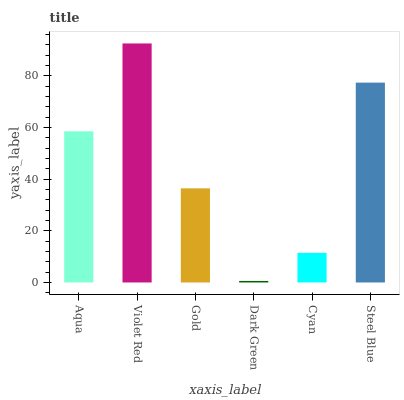Is Dark Green the minimum?
Answer yes or no. Yes. Is Violet Red the maximum?
Answer yes or no. Yes. Is Gold the minimum?
Answer yes or no. No. Is Gold the maximum?
Answer yes or no. No. Is Violet Red greater than Gold?
Answer yes or no. Yes. Is Gold less than Violet Red?
Answer yes or no. Yes. Is Gold greater than Violet Red?
Answer yes or no. No. Is Violet Red less than Gold?
Answer yes or no. No. Is Aqua the high median?
Answer yes or no. Yes. Is Gold the low median?
Answer yes or no. Yes. Is Violet Red the high median?
Answer yes or no. No. Is Aqua the low median?
Answer yes or no. No. 